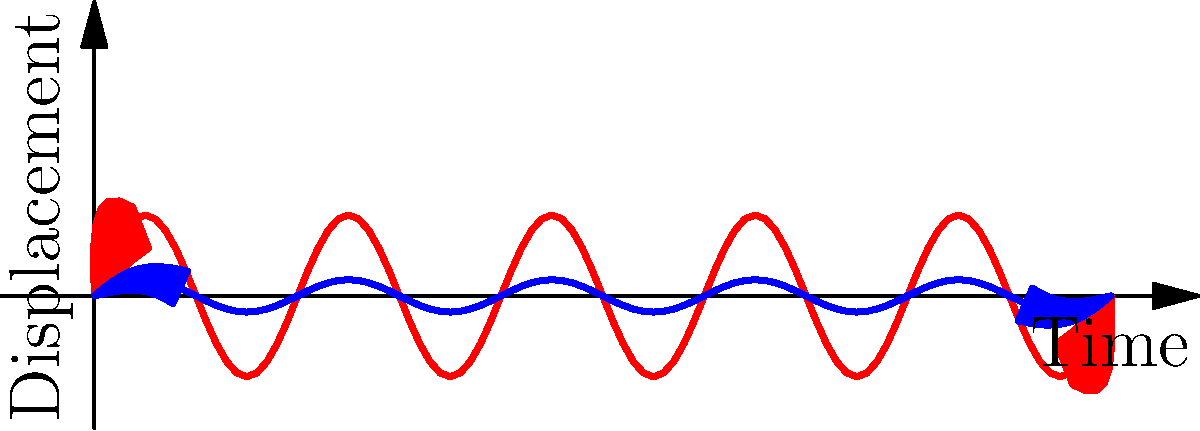As a paparazzi photographer, you're trying to capture a clear shot of a celebrity from a moving vehicle. Your camera's image stabilization system uses a gyroscope to detect angular motion. If the gyroscope detects an angular velocity of 0.1 rad/s and the focal length of your lens is 200 mm, what is the approximate linear displacement that the image stabilization system needs to compensate for in the image sensor to counteract the motion blur? To solve this problem, we need to follow these steps:

1. Understand the relationship between angular motion and linear displacement:
   The linear displacement (d) on the image sensor is related to the angular displacement (θ) and the focal length (f) by the formula:
   $$ d = f \tan(\theta) $$

2. For small angles, we can approximate $\tan(\theta)$ as $\theta$ (in radians):
   $$ d \approx f \theta $$

3. We're given an angular velocity (ω) rather than an angular displacement. We need to consider the exposure time (t) to convert velocity to displacement:
   $$ \theta = \omega t $$

4. Let's assume a typical exposure time for action shots, say 1/250 s:
   $$ t = \frac{1}{250} \text{ s} $$

5. Calculate the angular displacement:
   $$ \theta = 0.1 \text{ rad/s} \times \frac{1}{250} \text{ s} = 0.0004 \text{ rad} $$

6. Now we can calculate the linear displacement:
   $$ d \approx f \theta = 200 \text{ mm} \times 0.0004 \text{ rad} = 0.08 \text{ mm} $$

7. Convert to micrometers for a more practical unit in sensor movements:
   $$ d = 0.08 \text{ mm} \times 1000 \frac{\mu\text{m}}{\text{mm}} = 80 \mu\text{m} $$

Therefore, the image stabilization system needs to compensate for approximately 80 μm of displacement on the image sensor.
Answer: 80 μm 